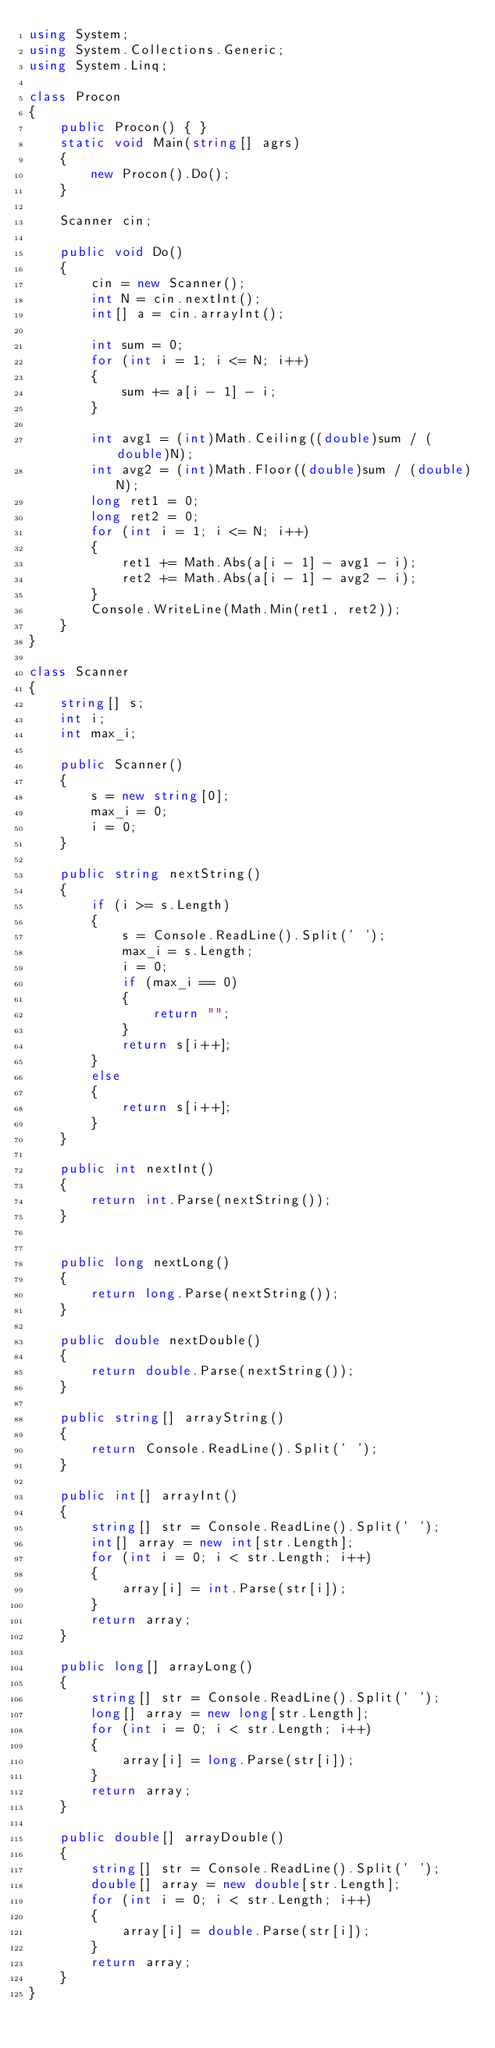Convert code to text. <code><loc_0><loc_0><loc_500><loc_500><_C#_>using System;
using System.Collections.Generic;
using System.Linq;

class Procon
{
    public Procon() { }
    static void Main(string[] agrs)
    {
        new Procon().Do();
    }

    Scanner cin;

    public void Do()
    {
        cin = new Scanner();
        int N = cin.nextInt();
        int[] a = cin.arrayInt();

        int sum = 0;
        for (int i = 1; i <= N; i++)
        {
            sum += a[i - 1] - i;
        }

        int avg1 = (int)Math.Ceiling((double)sum / (double)N);
        int avg2 = (int)Math.Floor((double)sum / (double)N);
        long ret1 = 0;
        long ret2 = 0;
        for (int i = 1; i <= N; i++)
        {
            ret1 += Math.Abs(a[i - 1] - avg1 - i);
            ret2 += Math.Abs(a[i - 1] - avg2 - i);
        }
        Console.WriteLine(Math.Min(ret1, ret2));
    }
}

class Scanner
{
    string[] s;
    int i;
    int max_i;

    public Scanner()
    {
        s = new string[0];
        max_i = 0;
        i = 0;
    }

    public string nextString()
    {
        if (i >= s.Length)
        {
            s = Console.ReadLine().Split(' ');
            max_i = s.Length;
            i = 0;
            if (max_i == 0)
            {
                return "";
            }
            return s[i++];
        }
        else
        {
            return s[i++];
        }
    }

    public int nextInt()
    {
        return int.Parse(nextString());
    }


    public long nextLong()
    {
        return long.Parse(nextString());
    }

    public double nextDouble()
    {
        return double.Parse(nextString());
    }

    public string[] arrayString()
    {
        return Console.ReadLine().Split(' ');
    }

    public int[] arrayInt()
    {
        string[] str = Console.ReadLine().Split(' ');
        int[] array = new int[str.Length];
        for (int i = 0; i < str.Length; i++)
        {
            array[i] = int.Parse(str[i]);
        }
        return array;
    }

    public long[] arrayLong()
    {
        string[] str = Console.ReadLine().Split(' ');
        long[] array = new long[str.Length];
        for (int i = 0; i < str.Length; i++)
        {
            array[i] = long.Parse(str[i]);
        }
        return array;
    }

    public double[] arrayDouble()
    {
        string[] str = Console.ReadLine().Split(' ');
        double[] array = new double[str.Length];
        for (int i = 0; i < str.Length; i++)
        {
            array[i] = double.Parse(str[i]);
        }
        return array;
    }
}</code> 